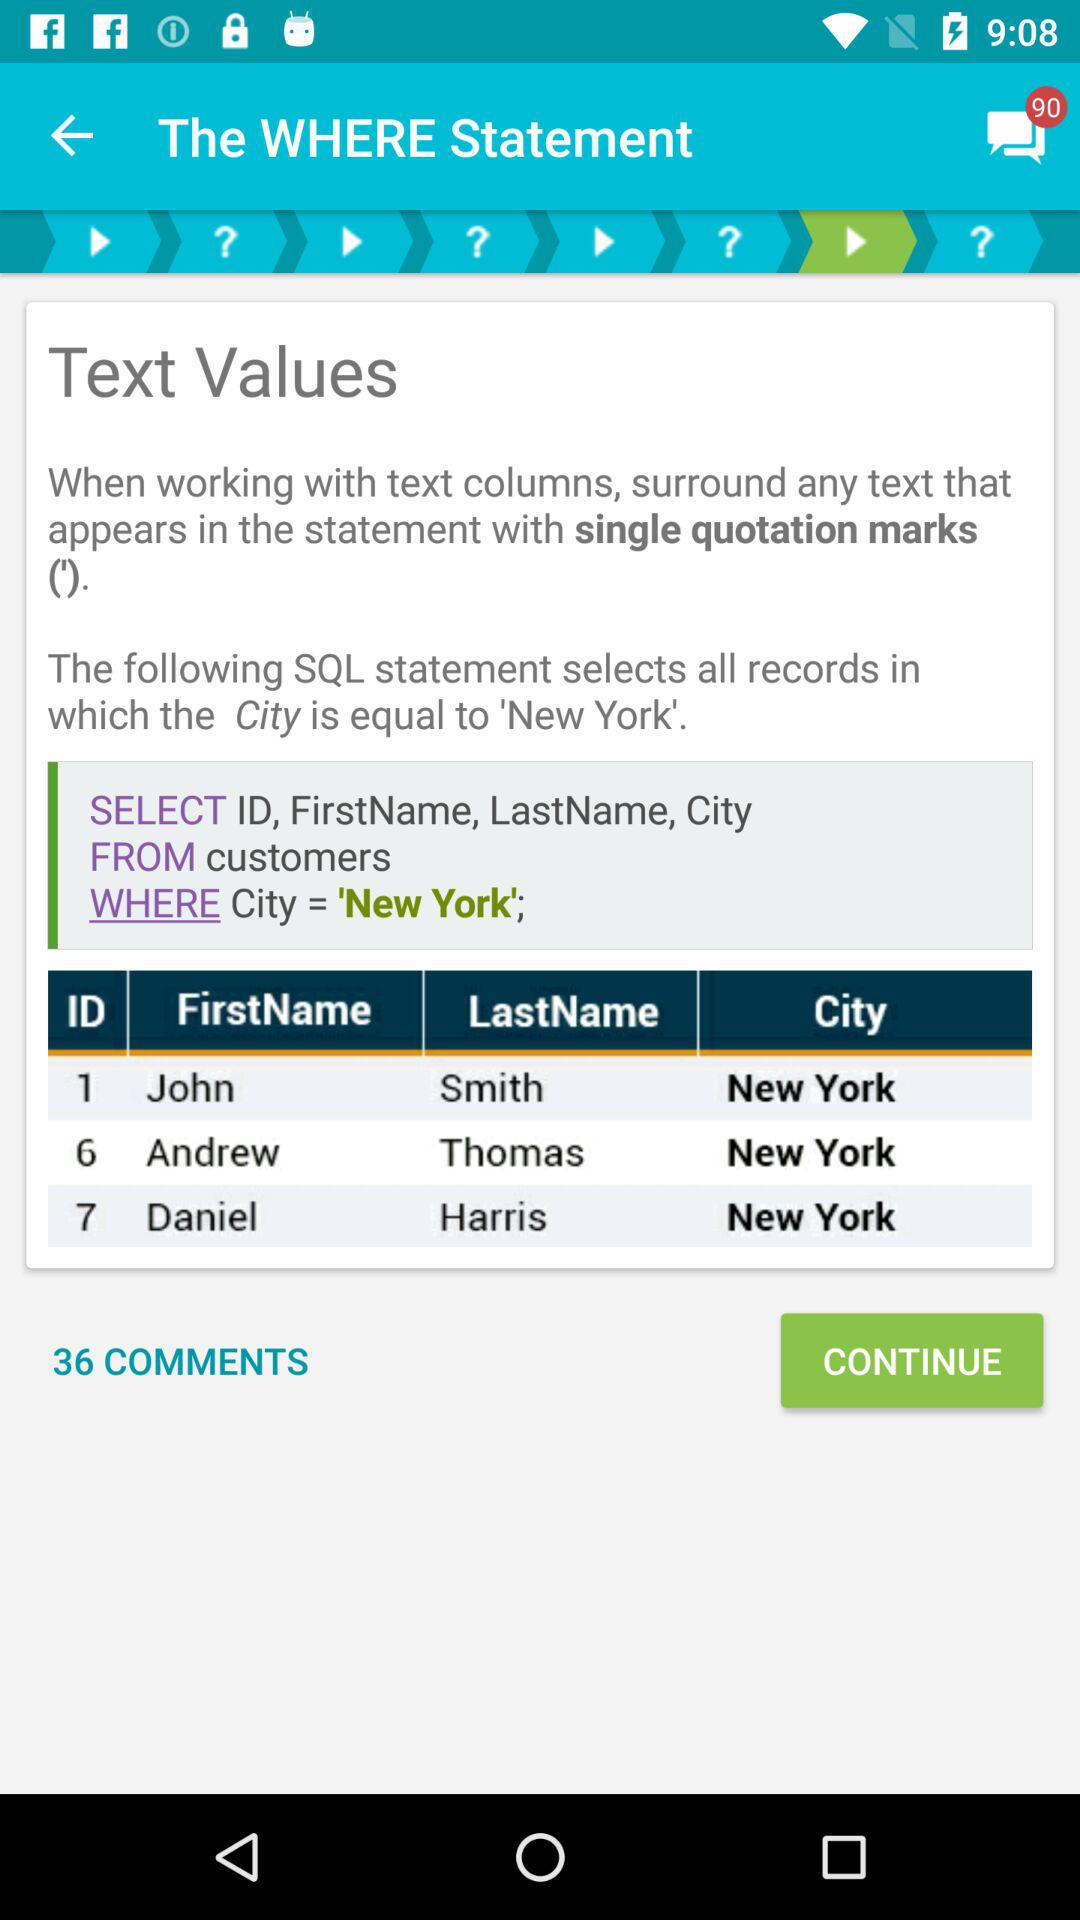How many records are displayed in the table?
Answer the question using a single word or phrase. 3 